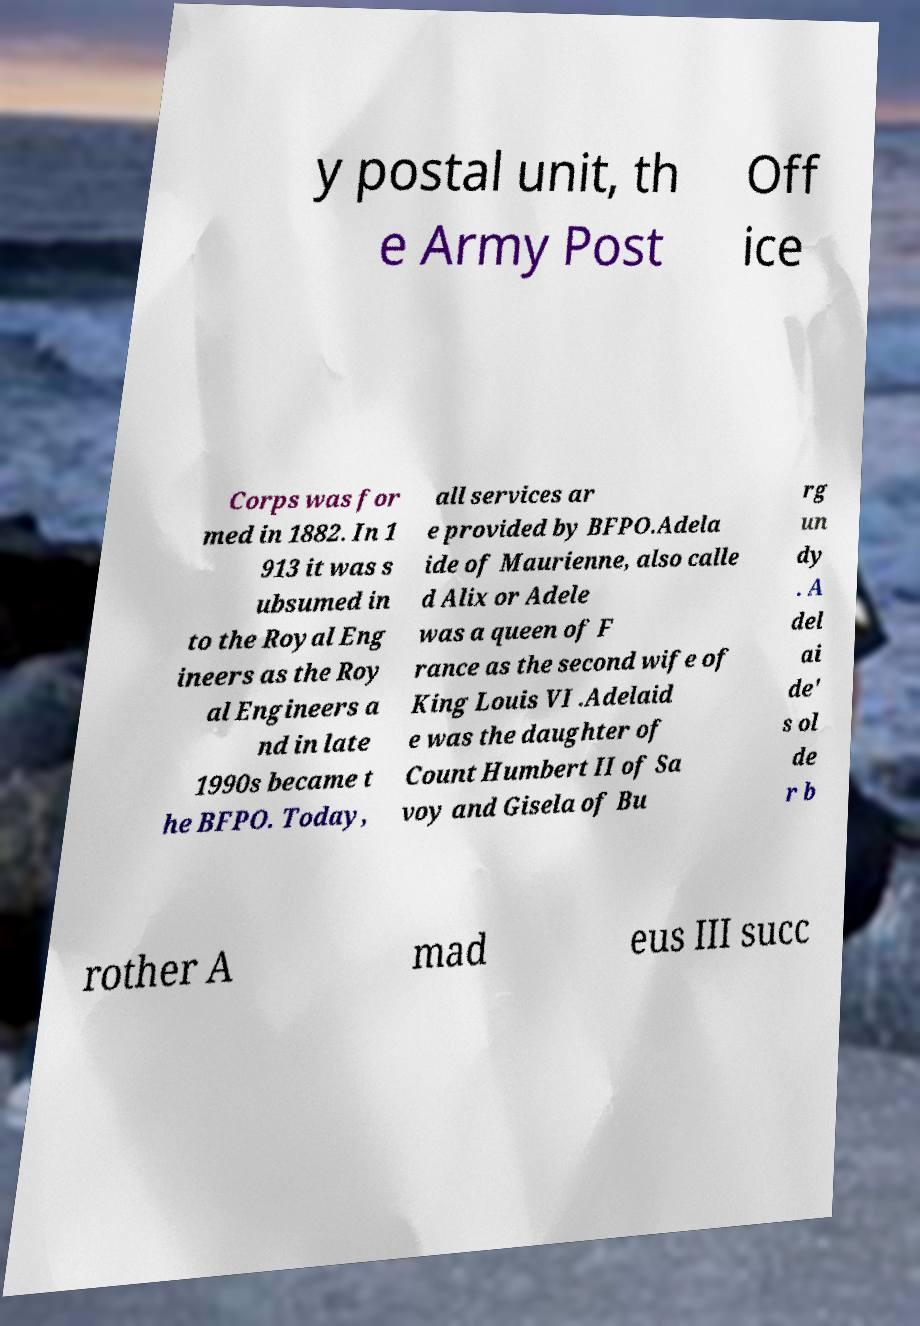Could you extract and type out the text from this image? y postal unit, th e Army Post Off ice Corps was for med in 1882. In 1 913 it was s ubsumed in to the Royal Eng ineers as the Roy al Engineers a nd in late 1990s became t he BFPO. Today, all services ar e provided by BFPO.Adela ide of Maurienne, also calle d Alix or Adele was a queen of F rance as the second wife of King Louis VI .Adelaid e was the daughter of Count Humbert II of Sa voy and Gisela of Bu rg un dy . A del ai de' s ol de r b rother A mad eus III succ 